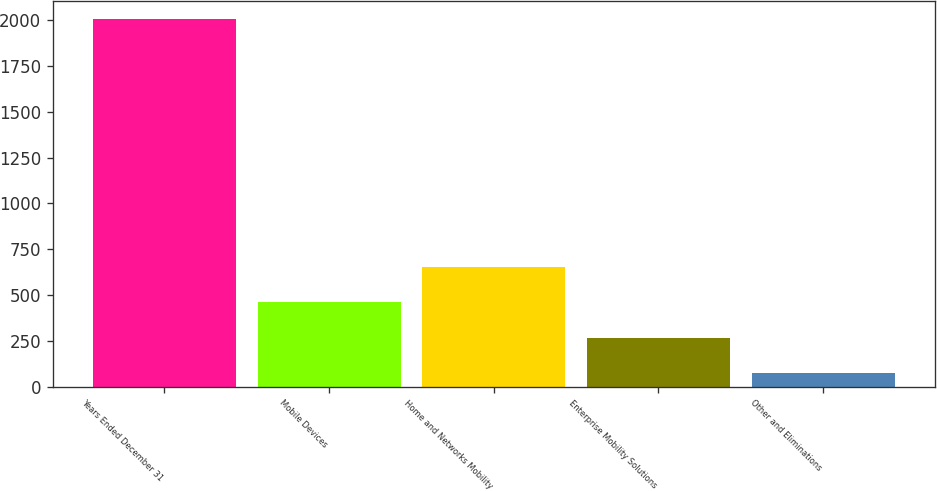Convert chart to OTSL. <chart><loc_0><loc_0><loc_500><loc_500><bar_chart><fcel>Years Ended December 31<fcel>Mobile Devices<fcel>Home and Networks Mobility<fcel>Enterprise Mobility Solutions<fcel>Other and Eliminations<nl><fcel>2006<fcel>459.6<fcel>652.9<fcel>266.3<fcel>73<nl></chart> 